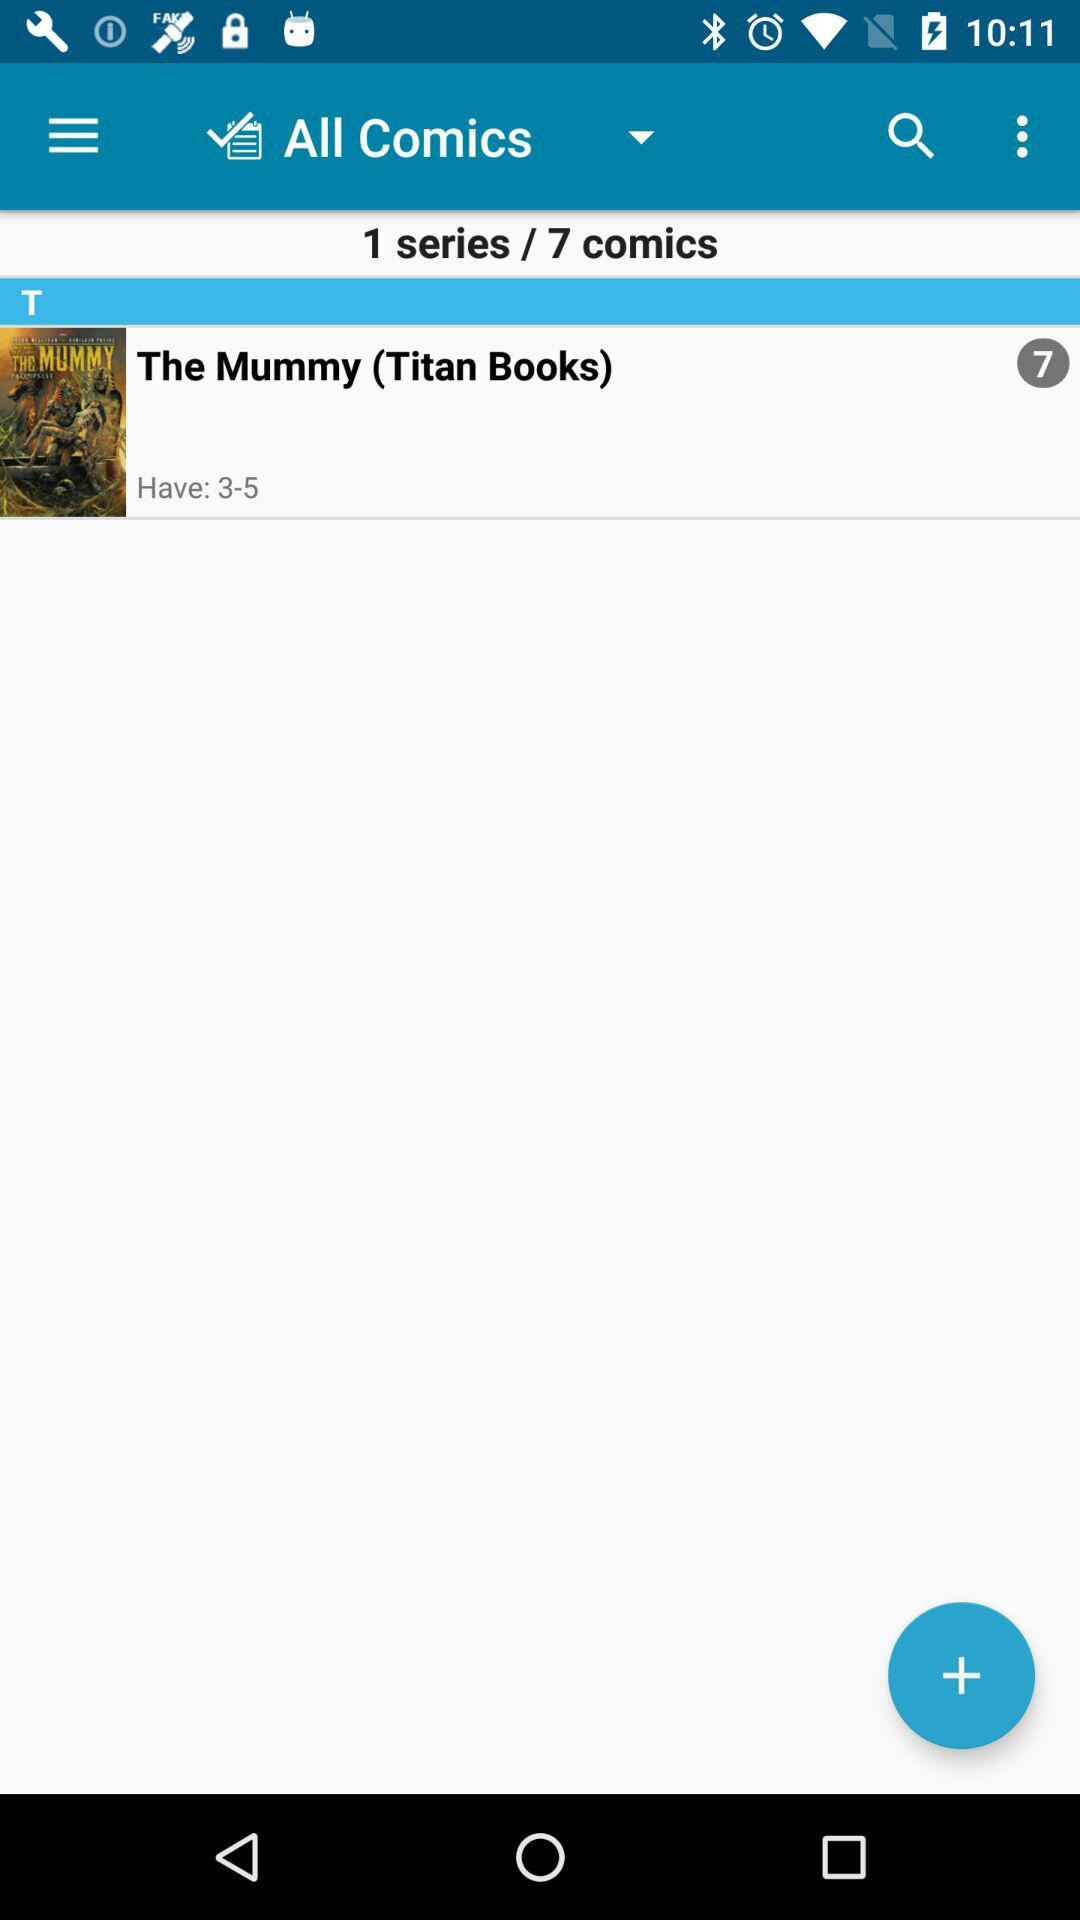What is the name of the given book? The name of the given book is "The Mummy". 